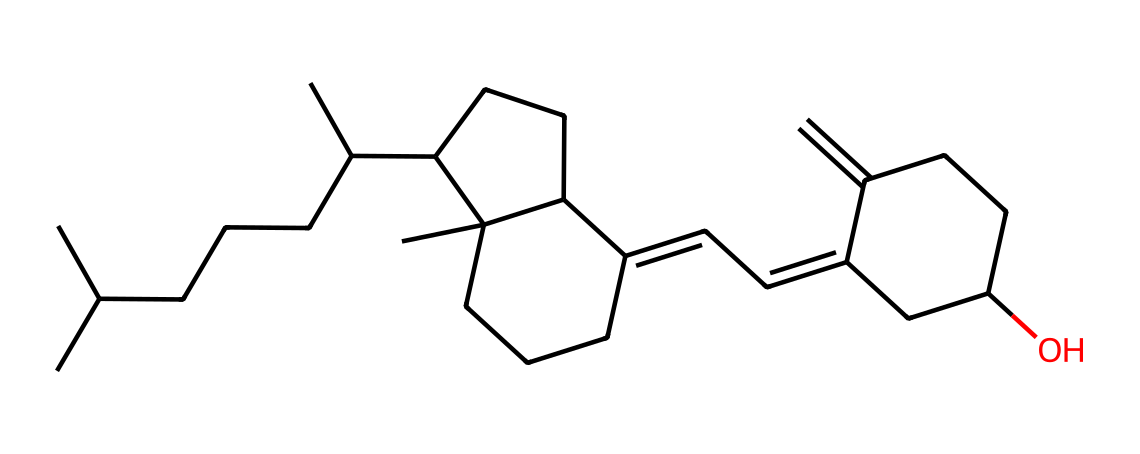How many carbons are in this compound? The SMILES representation shows various chains and rings of carbon atoms. Counting the 'C' atoms directly in the SMILES string indicates there are 30 carbon atoms.
Answer: 30 What is the functional group present in this molecular structure? Analyzing the structure, there is a hydroxyl group (-OH) indicated at the end of one of the carbon chains in the SMILES string, which corresponds to an alcohol functional group.
Answer: alcohol Is this molecule classified as a saturated or unsaturated hydrocarbons? Looking at the arrangement of carbon and hydrogen in the SMILES representation, there are double bonds and rings present, indicating unsaturation. Therefore, it is classified as an unsaturated hydrocarbon.
Answer: unsaturated How does the molecular structure of this vitamin correlate with its role in calcium metabolism? The presence of hydroxyl (-OH) groups in the steroid structure allows vitamin D to interact effectively with calcium in the body, enhancing calcium absorption and metabolism, which is vital for bone health.
Answer: enhances absorption What is the likely biological role of this chemical in disease prevention? Vitamin D is known for its role in immune system regulation and potentially preventing chronic diseases such as osteoporosis and certain cancers, primarily through its involvement in cell differentiation and proliferation.
Answer: immune regulation How many rings are present in the molecular structure? The structure contains two rings based on the cyclic portions indicated in the SMILES string, allowing a visual understanding of different functionalities provided by those rings.
Answer: 2 Is vitamin D fat-soluble, and how can this be determined from the structure? The long carbon chains and the presence of rings suggest lipid solubility, which is characteristic of fat-soluble vitamins like vitamin D. This is primarily observed through the nonpolar nature of the hydrocarbon portions.
Answer: yes 